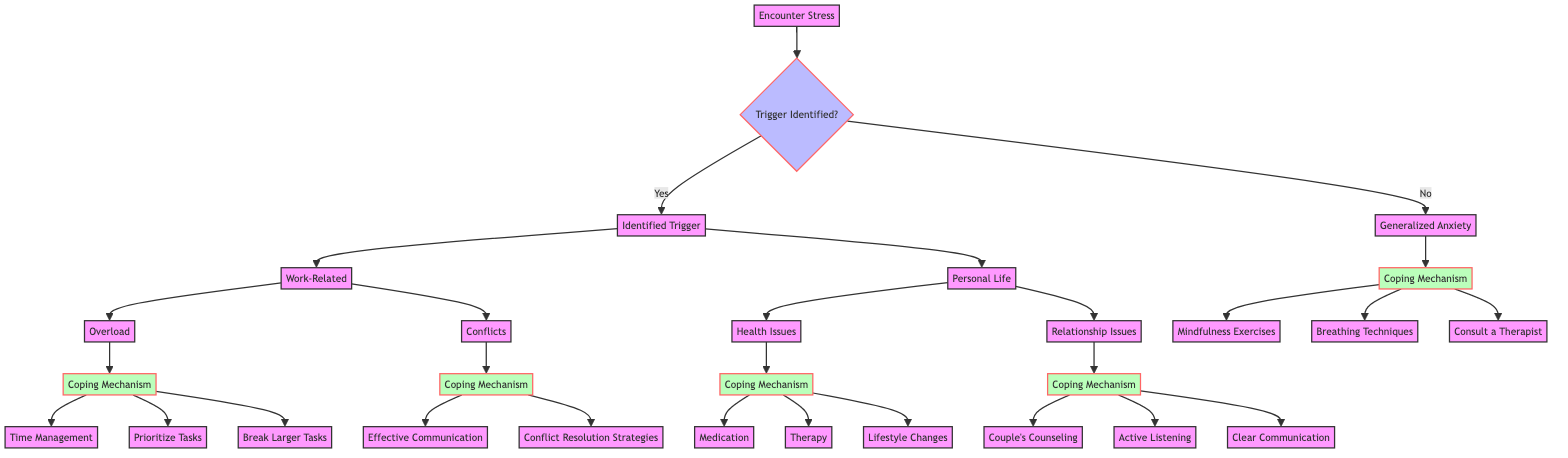What is the main node of the diagram? The main node is "Encounter Stress," which serves as the starting point for identifying stress responses and coping mechanisms.
Answer: Encounter Stress How many coping mechanisms are available for "Work-Related Conflicts"? There are two coping mechanisms available for "Conflicts," which are "Effective Communication" and "Conflict Resolution Strategies."
Answer: 2 What is the coping mechanism for "Work-Related Overload"? The coping mechanisms for "Overload" include "Time Management," "Prioritize Tasks," and "Break Larger Tasks."
Answer: Time Management What are the two categories under the node "Trigger Identified?" The two categories are "Yes" and "No," indicating whether a trigger for stress has been identified.
Answer: Yes, No Which coping mechanism is suggested for "Generalized Anxiety"? The coping mechanisms suggested for "Generalized Anxiety" include "Mindfulness Exercises," "Breathing Techniques," and "Consult a Therapist."
Answer: Mindfulness Exercises How many nodes are present under the "Personal Life" branch? There are two nodes present under "Personal Life," which are "Health Issues" and "Relationship Issues."
Answer: 2 What can be a coping mechanism for "Health Issues"? The coping mechanisms for "Health Issues" include "Medication," "Therapy," and "Lifestyle Changes."
Answer: Medication What follows after identifying a trigger of "Personal Life"? After identifying "Personal Life," the next step includes "Health Issues" or "Relationship Issues," leading to respective coping mechanisms for both.
Answer: Health Issues, Relationship Issues Which mechanism is related to improving communication in relationships? The coping mechanisms related to improving communication in relationships include "Couple's Counseling," "Active Listening," and "Clear Communication."
Answer: Couple's Counseling 